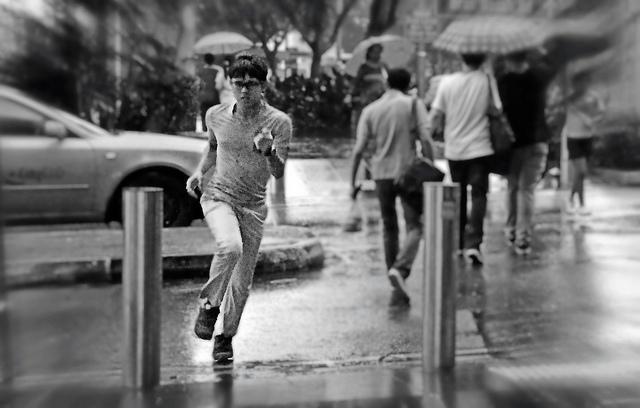What is the boy running through?
Pick the right solution, then justify: 'Answer: answer
Rationale: rationale.'
Options: Snow, rain, corn field, bar. Answer: rain.
Rationale: The boy is in an urban setting and is too young to enter a bar. there is no snow on the ground. 